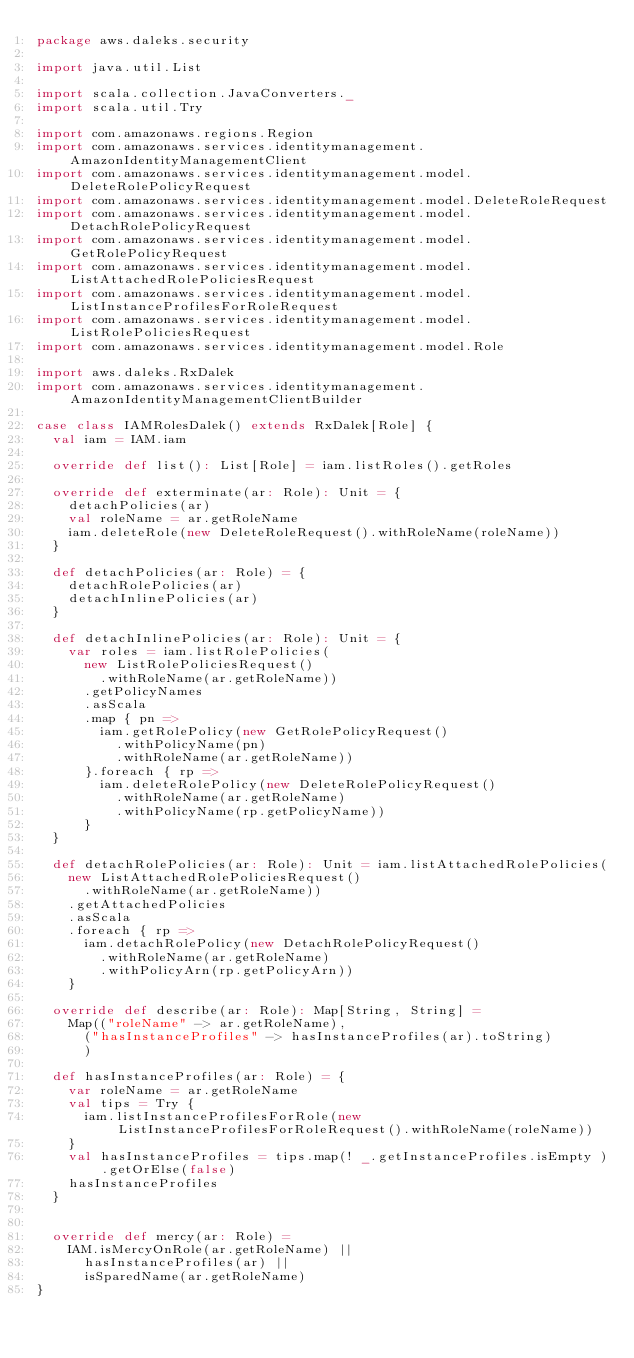Convert code to text. <code><loc_0><loc_0><loc_500><loc_500><_Scala_>package aws.daleks.security

import java.util.List

import scala.collection.JavaConverters._
import scala.util.Try

import com.amazonaws.regions.Region
import com.amazonaws.services.identitymanagement.AmazonIdentityManagementClient
import com.amazonaws.services.identitymanagement.model.DeleteRolePolicyRequest
import com.amazonaws.services.identitymanagement.model.DeleteRoleRequest
import com.amazonaws.services.identitymanagement.model.DetachRolePolicyRequest
import com.amazonaws.services.identitymanagement.model.GetRolePolicyRequest
import com.amazonaws.services.identitymanagement.model.ListAttachedRolePoliciesRequest
import com.amazonaws.services.identitymanagement.model.ListInstanceProfilesForRoleRequest
import com.amazonaws.services.identitymanagement.model.ListRolePoliciesRequest
import com.amazonaws.services.identitymanagement.model.Role

import aws.daleks.RxDalek
import com.amazonaws.services.identitymanagement.AmazonIdentityManagementClientBuilder

case class IAMRolesDalek() extends RxDalek[Role] {
  val iam = IAM.iam

  override def list(): List[Role] = iam.listRoles().getRoles

  override def exterminate(ar: Role): Unit = {
    detachPolicies(ar)
    val roleName = ar.getRoleName
    iam.deleteRole(new DeleteRoleRequest().withRoleName(roleName))
  }

  def detachPolicies(ar: Role) = {
    detachRolePolicies(ar)
    detachInlinePolicies(ar)
  }

  def detachInlinePolicies(ar: Role): Unit = {
    var roles = iam.listRolePolicies(
      new ListRolePoliciesRequest()
        .withRoleName(ar.getRoleName))
      .getPolicyNames
      .asScala
      .map { pn =>
        iam.getRolePolicy(new GetRolePolicyRequest()
          .withPolicyName(pn)
          .withRoleName(ar.getRoleName))
      }.foreach { rp =>
        iam.deleteRolePolicy(new DeleteRolePolicyRequest()
          .withRoleName(ar.getRoleName)
          .withPolicyName(rp.getPolicyName))
      }
  }

  def detachRolePolicies(ar: Role): Unit = iam.listAttachedRolePolicies(
    new ListAttachedRolePoliciesRequest()
      .withRoleName(ar.getRoleName))
    .getAttachedPolicies
    .asScala
    .foreach { rp =>
      iam.detachRolePolicy(new DetachRolePolicyRequest()
        .withRoleName(ar.getRoleName)
        .withPolicyArn(rp.getPolicyArn))
    }

  override def describe(ar: Role): Map[String, String] =
    Map(("roleName" -> ar.getRoleName),
      ("hasInstanceProfiles" -> hasInstanceProfiles(ar).toString)
      )

  def hasInstanceProfiles(ar: Role) = {
    var roleName = ar.getRoleName
    val tips = Try {
      iam.listInstanceProfilesForRole(new ListInstanceProfilesForRoleRequest().withRoleName(roleName))
    }
    val hasInstanceProfiles = tips.map(! _.getInstanceProfiles.isEmpty ).getOrElse(false)
    hasInstanceProfiles
  }


  override def mercy(ar: Role) =
    IAM.isMercyOnRole(ar.getRoleName) ||
      hasInstanceProfiles(ar) ||
      isSparedName(ar.getRoleName) 
}</code> 